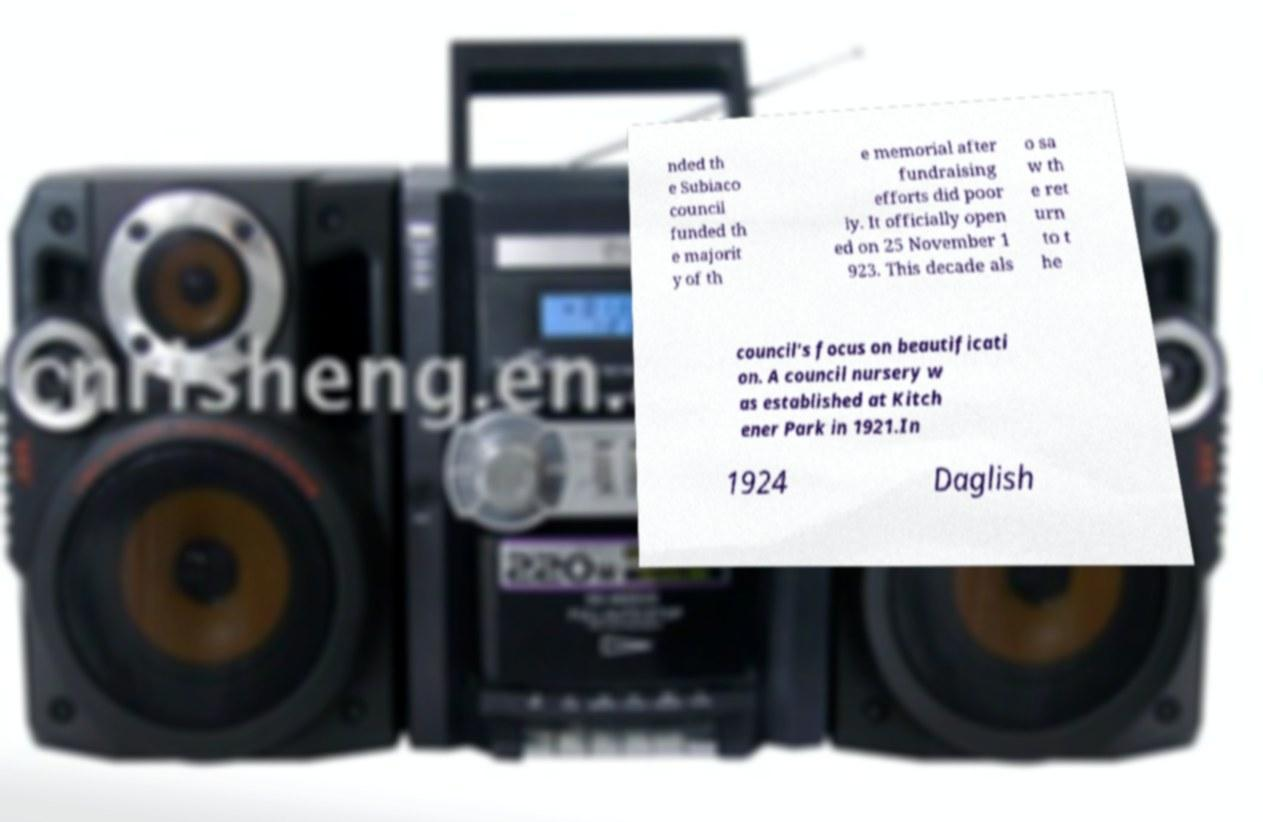For documentation purposes, I need the text within this image transcribed. Could you provide that? nded th e Subiaco council funded th e majorit y of th e memorial after fundraising efforts did poor ly. It officially open ed on 25 November 1 923. This decade als o sa w th e ret urn to t he council's focus on beautificati on. A council nursery w as established at Kitch ener Park in 1921.In 1924 Daglish 